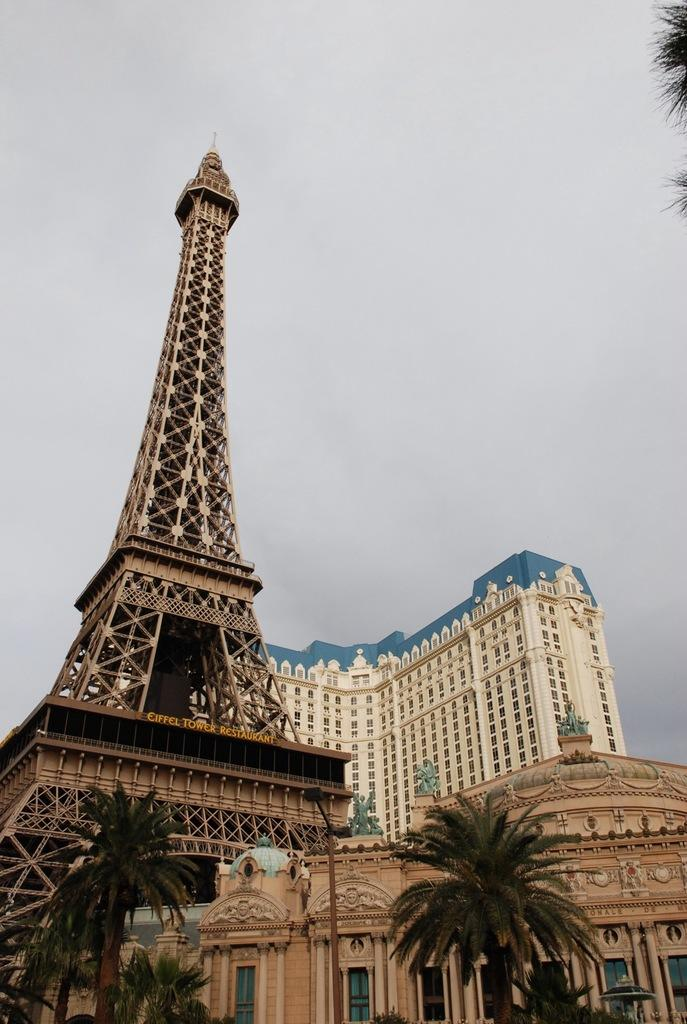What is located in the center of the image? There are buildings, windows, and a tower in the center of the image. What type of architectural feature is present in the center of the image? There is a tower in the center of the image. What can be seen at the bottom of the image? There are trees at the bottom of the image. What is visible at the top of the image? The sky is visible at the top of the image. Where is the throne located in the image? There is no throne present in the image. Can you see any bubbles floating in the sky in the image? There are no bubbles visible in the image. 